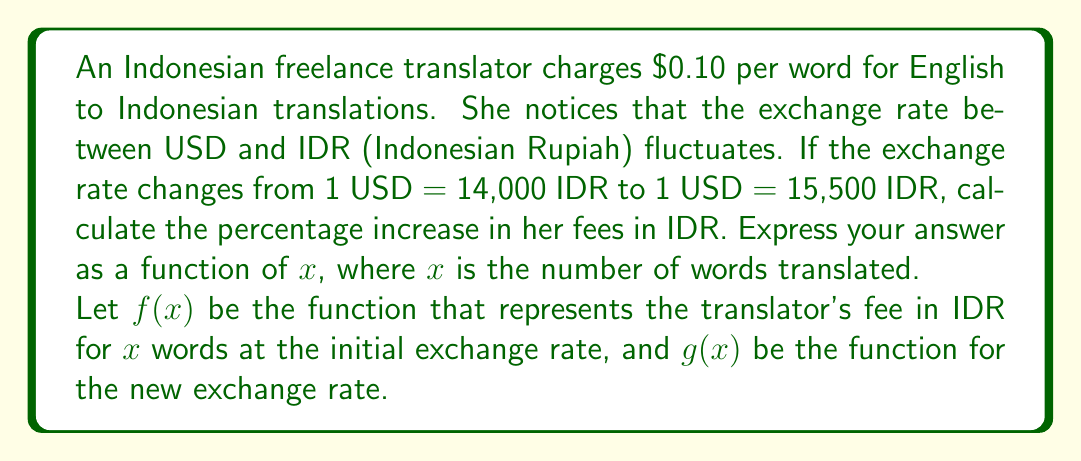What is the answer to this math problem? To solve this problem, we'll follow these steps:

1. Define the functions $f(x)$ and $g(x)$:
   $f(x) = 0.10 \cdot 14000 \cdot x$ (initial fee in IDR)
   $g(x) = 0.10 \cdot 15500 \cdot x$ (new fee in IDR)

2. Calculate the difference between the new and initial fees:
   $g(x) - f(x) = (0.10 \cdot 15500 \cdot x) - (0.10 \cdot 14000 \cdot x)$
                $= 0.10x(15500 - 14000)$
                $= 0.10x \cdot 1500$
                $= 150x$

3. Calculate the percentage increase:
   Percentage increase $= \frac{\text{Increase}}{\text{Original}} \cdot 100\%$
   $= \frac{g(x) - f(x)}{f(x)} \cdot 100\%$
   $= \frac{150x}{1400x} \cdot 100\%$
   $= \frac{150}{1400} \cdot 100\%$
   $= 0.10714285714 \cdot 100\%$
   $\approx 10.71\%$

The percentage increase is constant regardless of the number of words translated, so our final function doesn't depend on $x$.
Answer: The percentage increase in the translator's fees in IDR can be expressed as a constant function:

$h(x) = 10.71\%$

Where $x$ is the number of words translated, and the function always returns approximately 10.71%. 